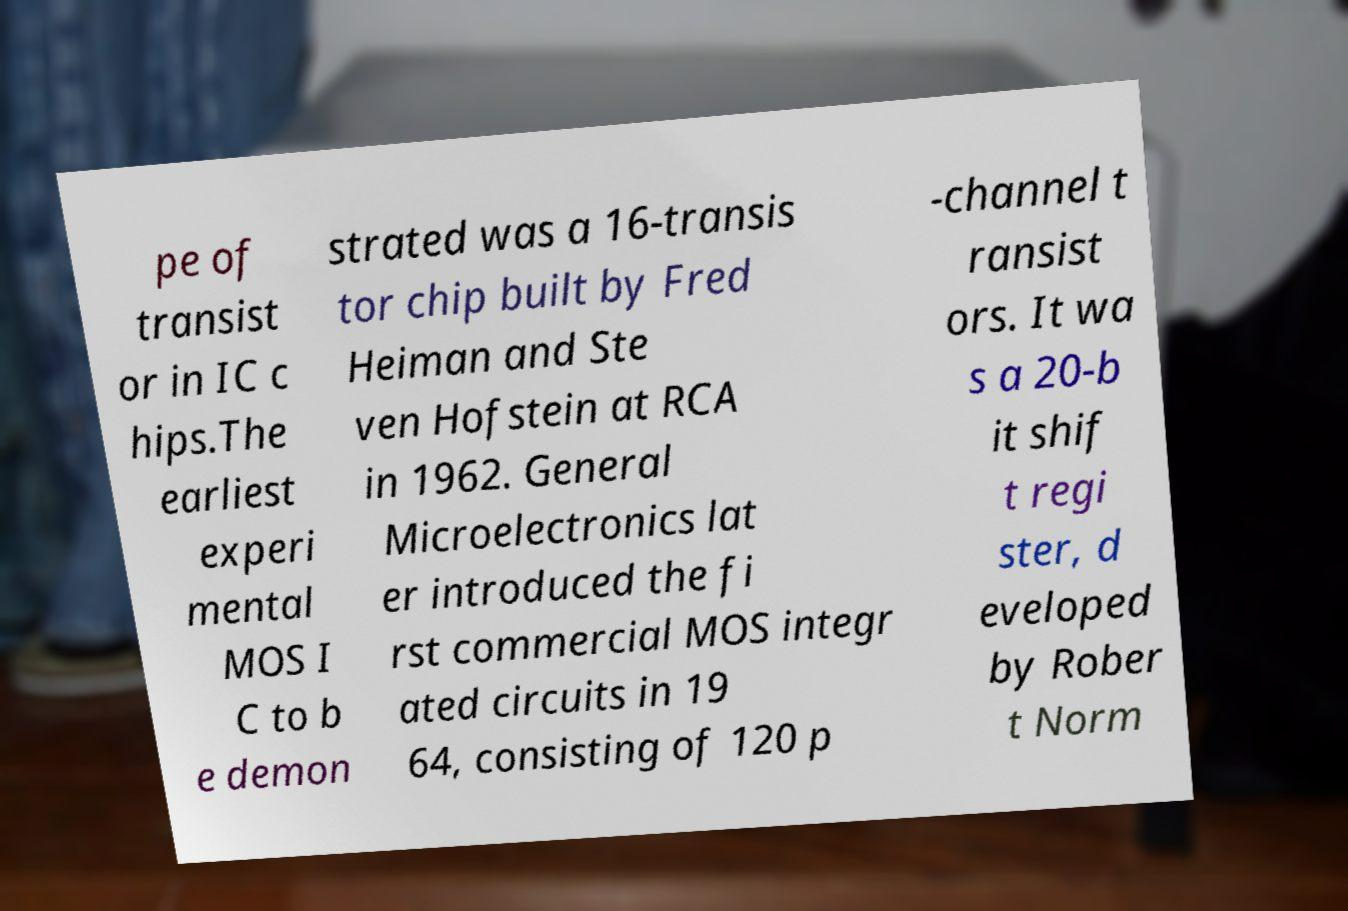Could you assist in decoding the text presented in this image and type it out clearly? pe of transist or in IC c hips.The earliest experi mental MOS I C to b e demon strated was a 16-transis tor chip built by Fred Heiman and Ste ven Hofstein at RCA in 1962. General Microelectronics lat er introduced the fi rst commercial MOS integr ated circuits in 19 64, consisting of 120 p -channel t ransist ors. It wa s a 20-b it shif t regi ster, d eveloped by Rober t Norm 